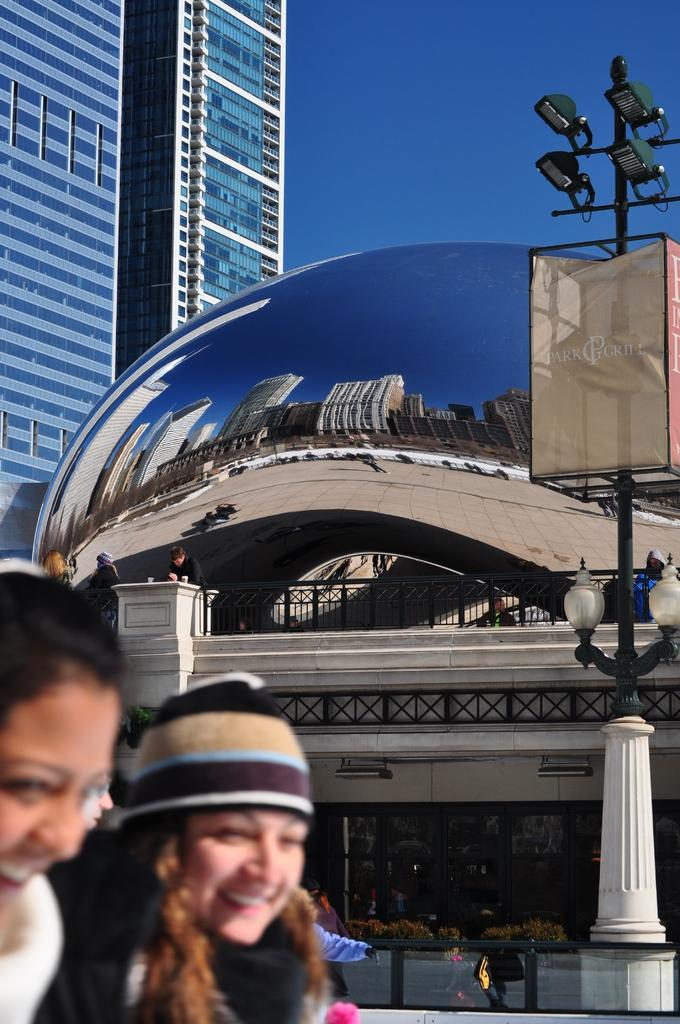Where are the women located in the image? The women are in the bottom right corner of the image. What can be seen in the background of the image? There is a building, a light pole, and persons in the background of the image. What is visible in the sky in the image? The sky is visible in the background of the image. What type of box is being used by the doll in the image? There is no doll or box present in the image. 